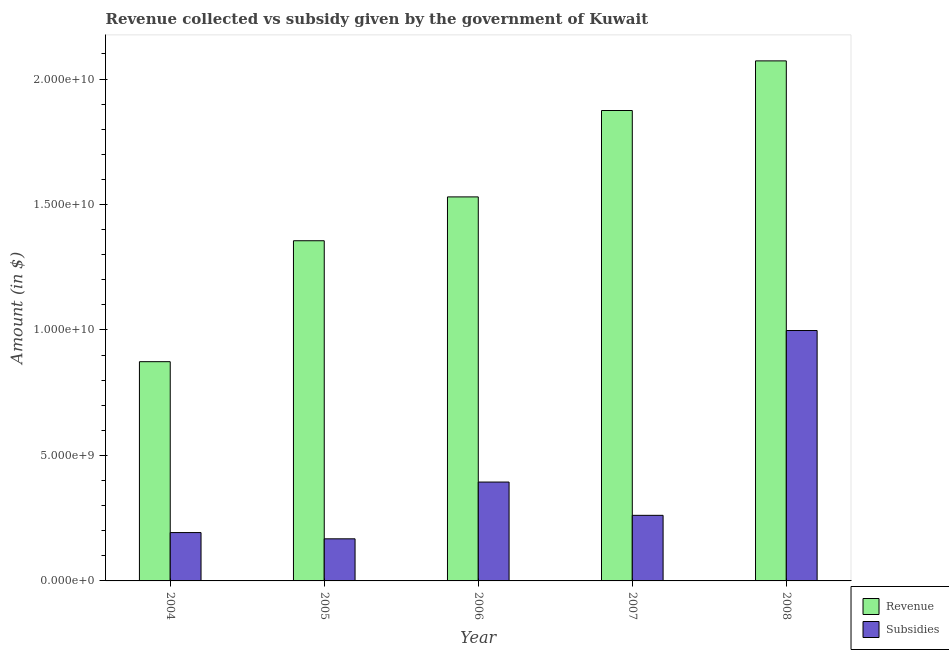How many groups of bars are there?
Your response must be concise. 5. Are the number of bars on each tick of the X-axis equal?
Provide a succinct answer. Yes. How many bars are there on the 5th tick from the left?
Your answer should be compact. 2. What is the label of the 1st group of bars from the left?
Your response must be concise. 2004. What is the amount of revenue collected in 2006?
Provide a succinct answer. 1.53e+1. Across all years, what is the maximum amount of subsidies given?
Your answer should be very brief. 9.98e+09. Across all years, what is the minimum amount of revenue collected?
Offer a terse response. 8.74e+09. In which year was the amount of revenue collected maximum?
Provide a short and direct response. 2008. What is the total amount of revenue collected in the graph?
Provide a short and direct response. 7.71e+1. What is the difference between the amount of subsidies given in 2004 and that in 2007?
Make the answer very short. -6.87e+08. What is the difference between the amount of subsidies given in 2005 and the amount of revenue collected in 2004?
Make the answer very short. -2.49e+08. What is the average amount of revenue collected per year?
Provide a short and direct response. 1.54e+1. In the year 2008, what is the difference between the amount of subsidies given and amount of revenue collected?
Keep it short and to the point. 0. In how many years, is the amount of subsidies given greater than 13000000000 $?
Offer a terse response. 0. What is the ratio of the amount of revenue collected in 2005 to that in 2006?
Give a very brief answer. 0.89. Is the amount of subsidies given in 2005 less than that in 2008?
Offer a terse response. Yes. Is the difference between the amount of subsidies given in 2005 and 2007 greater than the difference between the amount of revenue collected in 2005 and 2007?
Offer a very short reply. No. What is the difference between the highest and the second highest amount of subsidies given?
Offer a terse response. 6.04e+09. What is the difference between the highest and the lowest amount of revenue collected?
Provide a succinct answer. 1.20e+1. In how many years, is the amount of revenue collected greater than the average amount of revenue collected taken over all years?
Keep it short and to the point. 2. Is the sum of the amount of revenue collected in 2004 and 2005 greater than the maximum amount of subsidies given across all years?
Make the answer very short. Yes. What does the 1st bar from the left in 2008 represents?
Ensure brevity in your answer.  Revenue. What does the 2nd bar from the right in 2004 represents?
Make the answer very short. Revenue. How many bars are there?
Provide a short and direct response. 10. Are all the bars in the graph horizontal?
Ensure brevity in your answer.  No. How many years are there in the graph?
Give a very brief answer. 5. Does the graph contain grids?
Give a very brief answer. No. What is the title of the graph?
Offer a terse response. Revenue collected vs subsidy given by the government of Kuwait. Does "Researchers" appear as one of the legend labels in the graph?
Your response must be concise. No. What is the label or title of the X-axis?
Your response must be concise. Year. What is the label or title of the Y-axis?
Your answer should be very brief. Amount (in $). What is the Amount (in $) of Revenue in 2004?
Ensure brevity in your answer.  8.74e+09. What is the Amount (in $) of Subsidies in 2004?
Ensure brevity in your answer.  1.93e+09. What is the Amount (in $) in Revenue in 2005?
Offer a terse response. 1.36e+1. What is the Amount (in $) in Subsidies in 2005?
Ensure brevity in your answer.  1.68e+09. What is the Amount (in $) in Revenue in 2006?
Offer a terse response. 1.53e+1. What is the Amount (in $) of Subsidies in 2006?
Offer a terse response. 3.94e+09. What is the Amount (in $) of Revenue in 2007?
Provide a short and direct response. 1.87e+1. What is the Amount (in $) of Subsidies in 2007?
Your answer should be compact. 2.61e+09. What is the Amount (in $) in Revenue in 2008?
Keep it short and to the point. 2.07e+1. What is the Amount (in $) in Subsidies in 2008?
Your answer should be compact. 9.98e+09. Across all years, what is the maximum Amount (in $) of Revenue?
Provide a short and direct response. 2.07e+1. Across all years, what is the maximum Amount (in $) of Subsidies?
Your answer should be very brief. 9.98e+09. Across all years, what is the minimum Amount (in $) in Revenue?
Your answer should be very brief. 8.74e+09. Across all years, what is the minimum Amount (in $) of Subsidies?
Your response must be concise. 1.68e+09. What is the total Amount (in $) in Revenue in the graph?
Provide a short and direct response. 7.71e+1. What is the total Amount (in $) in Subsidies in the graph?
Offer a very short reply. 2.01e+1. What is the difference between the Amount (in $) of Revenue in 2004 and that in 2005?
Provide a succinct answer. -4.82e+09. What is the difference between the Amount (in $) in Subsidies in 2004 and that in 2005?
Provide a short and direct response. 2.49e+08. What is the difference between the Amount (in $) of Revenue in 2004 and that in 2006?
Offer a very short reply. -6.57e+09. What is the difference between the Amount (in $) in Subsidies in 2004 and that in 2006?
Offer a terse response. -2.01e+09. What is the difference between the Amount (in $) of Revenue in 2004 and that in 2007?
Keep it short and to the point. -1.00e+1. What is the difference between the Amount (in $) in Subsidies in 2004 and that in 2007?
Make the answer very short. -6.87e+08. What is the difference between the Amount (in $) of Revenue in 2004 and that in 2008?
Your response must be concise. -1.20e+1. What is the difference between the Amount (in $) in Subsidies in 2004 and that in 2008?
Provide a succinct answer. -8.05e+09. What is the difference between the Amount (in $) of Revenue in 2005 and that in 2006?
Provide a short and direct response. -1.75e+09. What is the difference between the Amount (in $) of Subsidies in 2005 and that in 2006?
Keep it short and to the point. -2.26e+09. What is the difference between the Amount (in $) of Revenue in 2005 and that in 2007?
Ensure brevity in your answer.  -5.19e+09. What is the difference between the Amount (in $) of Subsidies in 2005 and that in 2007?
Ensure brevity in your answer.  -9.36e+08. What is the difference between the Amount (in $) in Revenue in 2005 and that in 2008?
Offer a terse response. -7.17e+09. What is the difference between the Amount (in $) of Subsidies in 2005 and that in 2008?
Ensure brevity in your answer.  -8.30e+09. What is the difference between the Amount (in $) in Revenue in 2006 and that in 2007?
Your answer should be compact. -3.44e+09. What is the difference between the Amount (in $) in Subsidies in 2006 and that in 2007?
Keep it short and to the point. 1.33e+09. What is the difference between the Amount (in $) of Revenue in 2006 and that in 2008?
Provide a succinct answer. -5.42e+09. What is the difference between the Amount (in $) in Subsidies in 2006 and that in 2008?
Your answer should be very brief. -6.04e+09. What is the difference between the Amount (in $) of Revenue in 2007 and that in 2008?
Keep it short and to the point. -1.98e+09. What is the difference between the Amount (in $) in Subsidies in 2007 and that in 2008?
Ensure brevity in your answer.  -7.36e+09. What is the difference between the Amount (in $) of Revenue in 2004 and the Amount (in $) of Subsidies in 2005?
Offer a terse response. 7.06e+09. What is the difference between the Amount (in $) of Revenue in 2004 and the Amount (in $) of Subsidies in 2006?
Make the answer very short. 4.80e+09. What is the difference between the Amount (in $) in Revenue in 2004 and the Amount (in $) in Subsidies in 2007?
Offer a terse response. 6.12e+09. What is the difference between the Amount (in $) of Revenue in 2004 and the Amount (in $) of Subsidies in 2008?
Provide a short and direct response. -1.24e+09. What is the difference between the Amount (in $) in Revenue in 2005 and the Amount (in $) in Subsidies in 2006?
Offer a terse response. 9.62e+09. What is the difference between the Amount (in $) of Revenue in 2005 and the Amount (in $) of Subsidies in 2007?
Make the answer very short. 1.09e+1. What is the difference between the Amount (in $) of Revenue in 2005 and the Amount (in $) of Subsidies in 2008?
Your response must be concise. 3.58e+09. What is the difference between the Amount (in $) in Revenue in 2006 and the Amount (in $) in Subsidies in 2007?
Your response must be concise. 1.27e+1. What is the difference between the Amount (in $) of Revenue in 2006 and the Amount (in $) of Subsidies in 2008?
Make the answer very short. 5.32e+09. What is the difference between the Amount (in $) of Revenue in 2007 and the Amount (in $) of Subsidies in 2008?
Your answer should be very brief. 8.77e+09. What is the average Amount (in $) in Revenue per year?
Offer a terse response. 1.54e+1. What is the average Amount (in $) of Subsidies per year?
Keep it short and to the point. 4.03e+09. In the year 2004, what is the difference between the Amount (in $) of Revenue and Amount (in $) of Subsidies?
Your answer should be very brief. 6.81e+09. In the year 2005, what is the difference between the Amount (in $) in Revenue and Amount (in $) in Subsidies?
Offer a very short reply. 1.19e+1. In the year 2006, what is the difference between the Amount (in $) in Revenue and Amount (in $) in Subsidies?
Your answer should be compact. 1.14e+1. In the year 2007, what is the difference between the Amount (in $) in Revenue and Amount (in $) in Subsidies?
Keep it short and to the point. 1.61e+1. In the year 2008, what is the difference between the Amount (in $) in Revenue and Amount (in $) in Subsidies?
Provide a short and direct response. 1.07e+1. What is the ratio of the Amount (in $) in Revenue in 2004 to that in 2005?
Keep it short and to the point. 0.64. What is the ratio of the Amount (in $) in Subsidies in 2004 to that in 2005?
Your response must be concise. 1.15. What is the ratio of the Amount (in $) in Revenue in 2004 to that in 2006?
Your answer should be compact. 0.57. What is the ratio of the Amount (in $) in Subsidies in 2004 to that in 2006?
Provide a succinct answer. 0.49. What is the ratio of the Amount (in $) of Revenue in 2004 to that in 2007?
Provide a succinct answer. 0.47. What is the ratio of the Amount (in $) in Subsidies in 2004 to that in 2007?
Provide a short and direct response. 0.74. What is the ratio of the Amount (in $) of Revenue in 2004 to that in 2008?
Make the answer very short. 0.42. What is the ratio of the Amount (in $) of Subsidies in 2004 to that in 2008?
Offer a very short reply. 0.19. What is the ratio of the Amount (in $) in Revenue in 2005 to that in 2006?
Provide a succinct answer. 0.89. What is the ratio of the Amount (in $) of Subsidies in 2005 to that in 2006?
Keep it short and to the point. 0.43. What is the ratio of the Amount (in $) in Revenue in 2005 to that in 2007?
Provide a short and direct response. 0.72. What is the ratio of the Amount (in $) of Subsidies in 2005 to that in 2007?
Your answer should be compact. 0.64. What is the ratio of the Amount (in $) in Revenue in 2005 to that in 2008?
Make the answer very short. 0.65. What is the ratio of the Amount (in $) in Subsidies in 2005 to that in 2008?
Make the answer very short. 0.17. What is the ratio of the Amount (in $) in Revenue in 2006 to that in 2007?
Your answer should be compact. 0.82. What is the ratio of the Amount (in $) of Subsidies in 2006 to that in 2007?
Offer a very short reply. 1.51. What is the ratio of the Amount (in $) in Revenue in 2006 to that in 2008?
Your answer should be very brief. 0.74. What is the ratio of the Amount (in $) of Subsidies in 2006 to that in 2008?
Keep it short and to the point. 0.39. What is the ratio of the Amount (in $) in Revenue in 2007 to that in 2008?
Provide a succinct answer. 0.9. What is the ratio of the Amount (in $) of Subsidies in 2007 to that in 2008?
Provide a succinct answer. 0.26. What is the difference between the highest and the second highest Amount (in $) of Revenue?
Keep it short and to the point. 1.98e+09. What is the difference between the highest and the second highest Amount (in $) in Subsidies?
Ensure brevity in your answer.  6.04e+09. What is the difference between the highest and the lowest Amount (in $) of Revenue?
Ensure brevity in your answer.  1.20e+1. What is the difference between the highest and the lowest Amount (in $) in Subsidies?
Provide a succinct answer. 8.30e+09. 